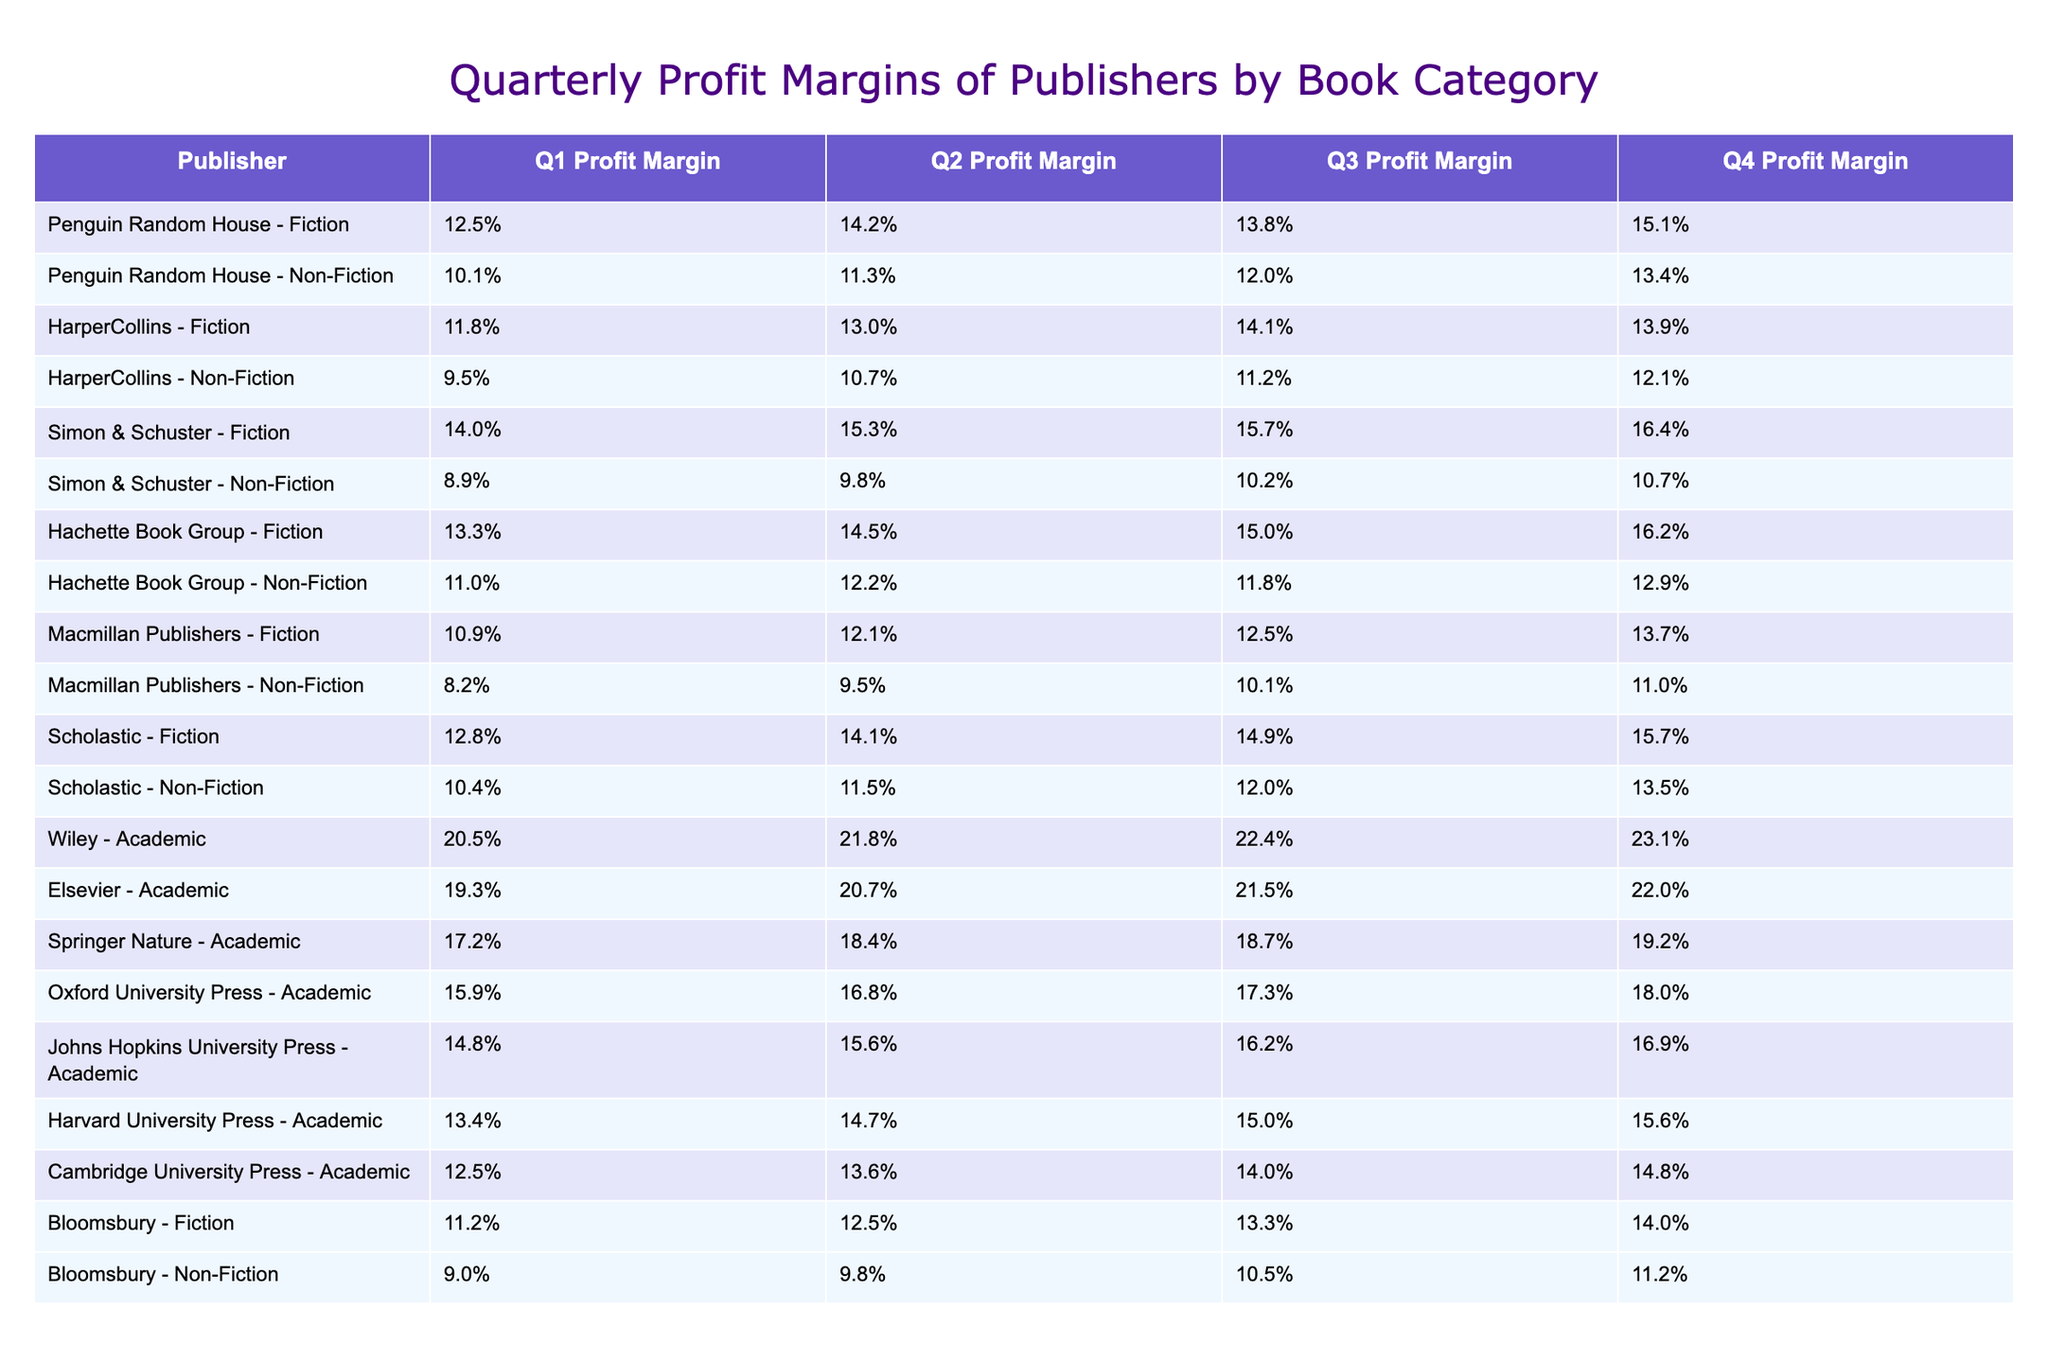What is the highest Q4 Profit Margin for Fiction? Looking at the Q4 Profit Margin for Fiction, Simon & Schuster has the highest percentage at 16.4%.
Answer: 16.4% Which publisher has the lowest Q1 Profit Margin for Non-Fiction? For Non-Fiction in Q1, Macmillan Publishers has the lowest Profit Margin at 8.2%.
Answer: 8.2% What is the average Q2 Profit Margin for Academic books? To find the average Q2 Profit Margin for Academic books, we sum the following values: 21.8% + 20.7% + 18.4% + 16.8% + 15.6% + 14.7% + 13.6% = 121.6%. Dividing by 7, we get an average of 121.6/7 = 17.3%.
Answer: 17.3% Is there any publisher that consistently has a Profit Margin above 10% in all quarters for Non-Fiction? By examining each Non-Fiction publisher’s Profit Margin across all four quarters, both Penguin Random House and Hachette Book Group have margins above 10% in every quarter, confirming that they meet the criteria.
Answer: Yes What is the difference in Q3 Profit Margin between the highest Academic publisher and the lowest? The highest Q3 Profit Margin for Academic publishers is Wiley at 22.4%, and the lowest is Cambridge University Press at 14.0%. The difference is calculated as 22.4% - 14.0% = 8.4%.
Answer: 8.4% Which publisher increases its Q4 Profit Margin for Fiction the most from Q1 to Q4? To determine this, we analyze the increase for each Fiction publisher: Penguin Random House: 15.1% - 12.5% = 2.6%, HarperCollins: 13.9% - 11.8% = 2.1%, Simon & Schuster: 16.4% - 14.0% = 2.4%, Hachette Book Group: 16.2% - 13.3% = 2.9%, Scholastic: 15.7% - 12.8% = 2.9%. Hachette and Scholastic both show the highest increase of 2.9%.
Answer: Hachette Book Group and Scholastic What percentage of Academic publishers showed an increase in Profit Margin from Q1 to Q4? By reviewing the Q1 and Q4 Profit Margins, we tally that Wiley, Elsevier, and Springer Nature all showed increases, while Johns Hopkins University Press, Harvard University Press, and Cambridge University Press see fluctuating or smaller increases. Thus, 4 out of 7 Academic publishers increased their Q4 margins compared to Q1 margins.
Answer: Approximately 57% What is the total Profit Margin of Fiction and Non-Fiction for Penguin Random House in Q2? For Q2, the Profit Margin for Penguin Random House in Fiction is 14.2% and for Non-Fiction is 11.3%. The total is calculated by adding these two figures: 14.2% + 11.3% = 25.5%.
Answer: 25.5% Which category does the publisher Wiley belong to, and what is its Q1 Profit Margin? Wiley belongs to the Academic category, and its Q1 Profit Margin is 20.5%.
Answer: Academic, 20.5% 